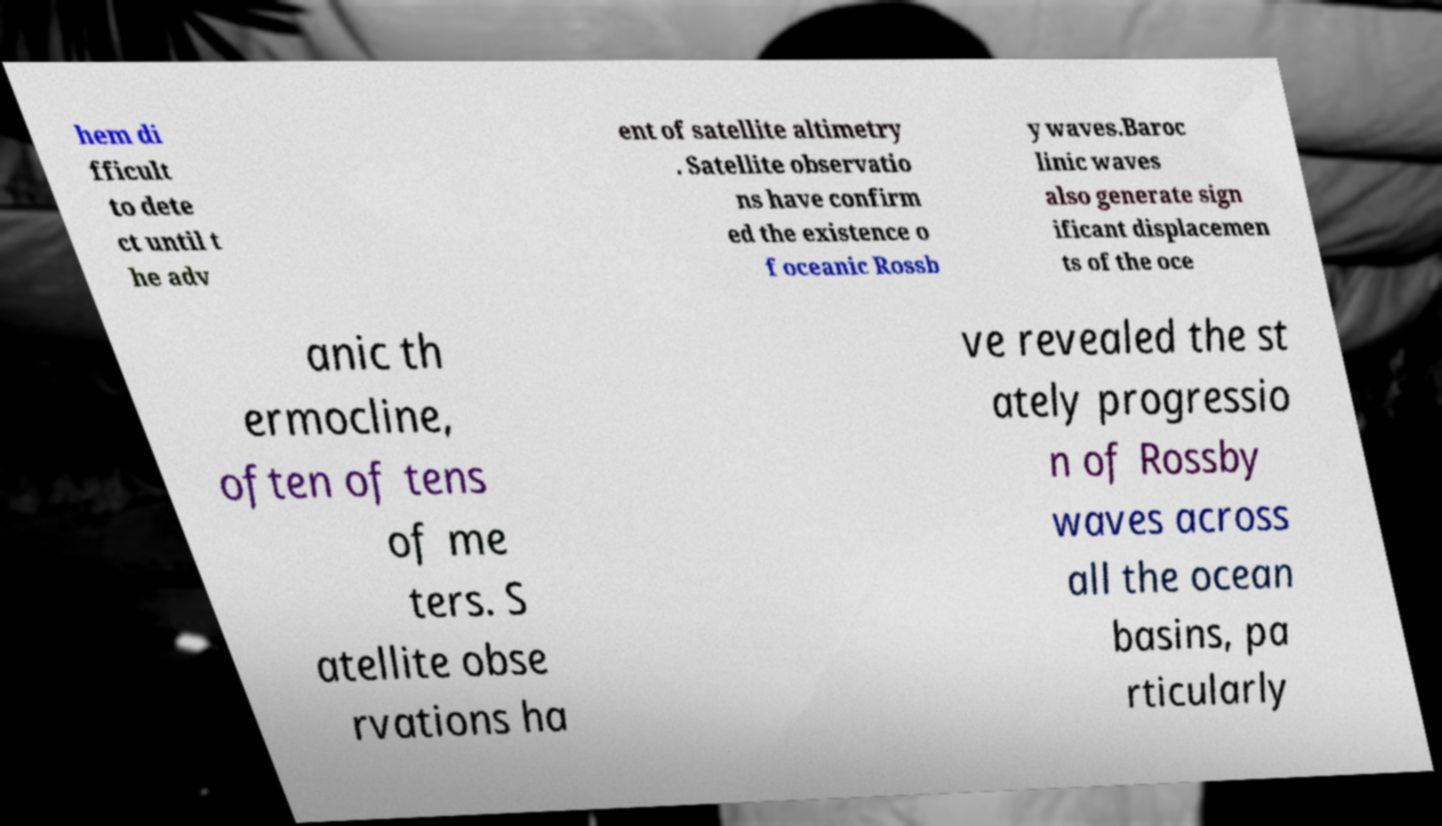Please identify and transcribe the text found in this image. hem di fficult to dete ct until t he adv ent of satellite altimetry . Satellite observatio ns have confirm ed the existence o f oceanic Rossb y waves.Baroc linic waves also generate sign ificant displacemen ts of the oce anic th ermocline, often of tens of me ters. S atellite obse rvations ha ve revealed the st ately progressio n of Rossby waves across all the ocean basins, pa rticularly 